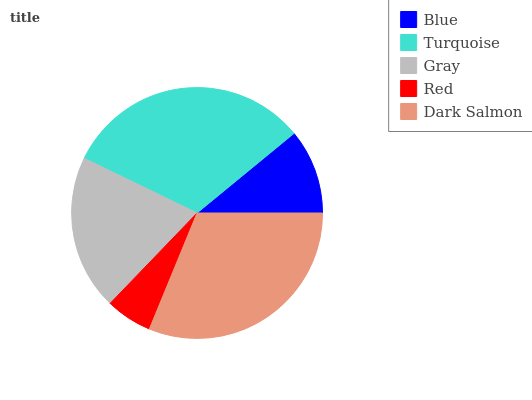Is Red the minimum?
Answer yes or no. Yes. Is Turquoise the maximum?
Answer yes or no. Yes. Is Gray the minimum?
Answer yes or no. No. Is Gray the maximum?
Answer yes or no. No. Is Turquoise greater than Gray?
Answer yes or no. Yes. Is Gray less than Turquoise?
Answer yes or no. Yes. Is Gray greater than Turquoise?
Answer yes or no. No. Is Turquoise less than Gray?
Answer yes or no. No. Is Gray the high median?
Answer yes or no. Yes. Is Gray the low median?
Answer yes or no. Yes. Is Turquoise the high median?
Answer yes or no. No. Is Turquoise the low median?
Answer yes or no. No. 